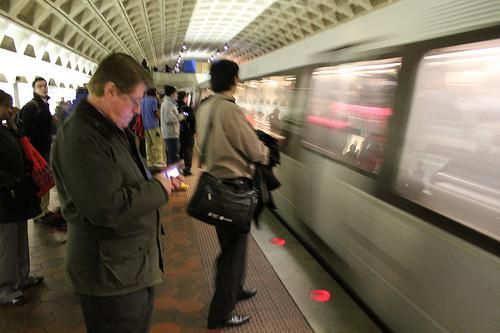Question: what is the setting of the photo?
Choices:
A. A train platform.
B. A bus terminal.
C. An airport.
D. A subway station.
Answer with the letter. Answer: D Question: what are the people waiting for?
Choices:
A. The bus.
B. The taxi cab.
C. The train.
D. The airplane.
Answer with the letter. Answer: C Question: who is checking his cell phone?
Choices:
A. The woman at the bar.
B. The girl in the yoga class.
C. The boy on the football field.
D. A man with glasses.
Answer with the letter. Answer: D Question: why is the train blurry?
Choices:
A. Out of focus.
B. Not good camera.
C. It is in motion.
D. Picture bad quality.
Answer with the letter. Answer: C Question: how is the ceiling shaped?
Choices:
A. It is flat.
B. It is round.
C. It is in a square.
D. It is curved.
Answer with the letter. Answer: D Question: where are the people standing?
Choices:
A. On the platform.
B. At the bus depot.
C. In the airport.
D. In the subway terminal.
Answer with the letter. Answer: A 